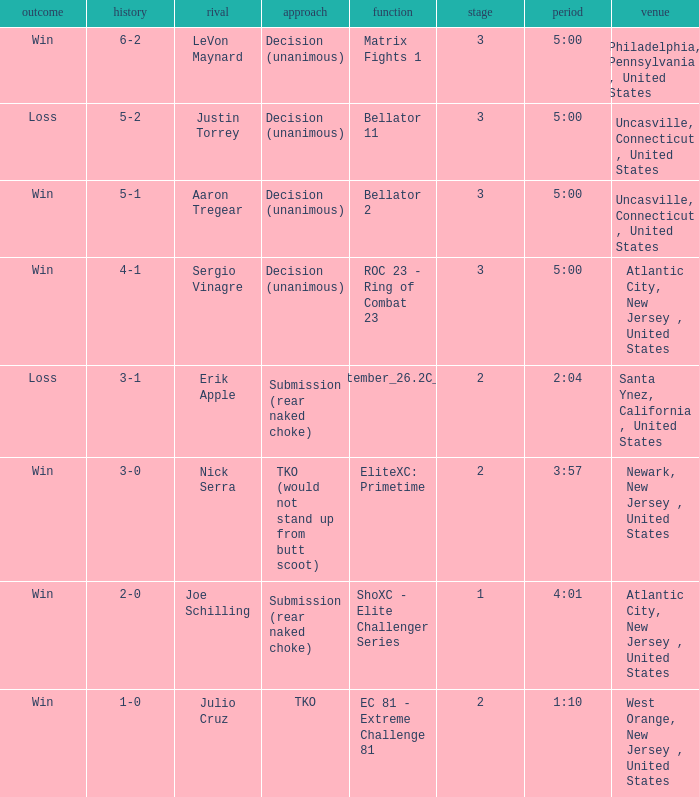Who was the opponent when there was a TKO method? Julio Cruz. 